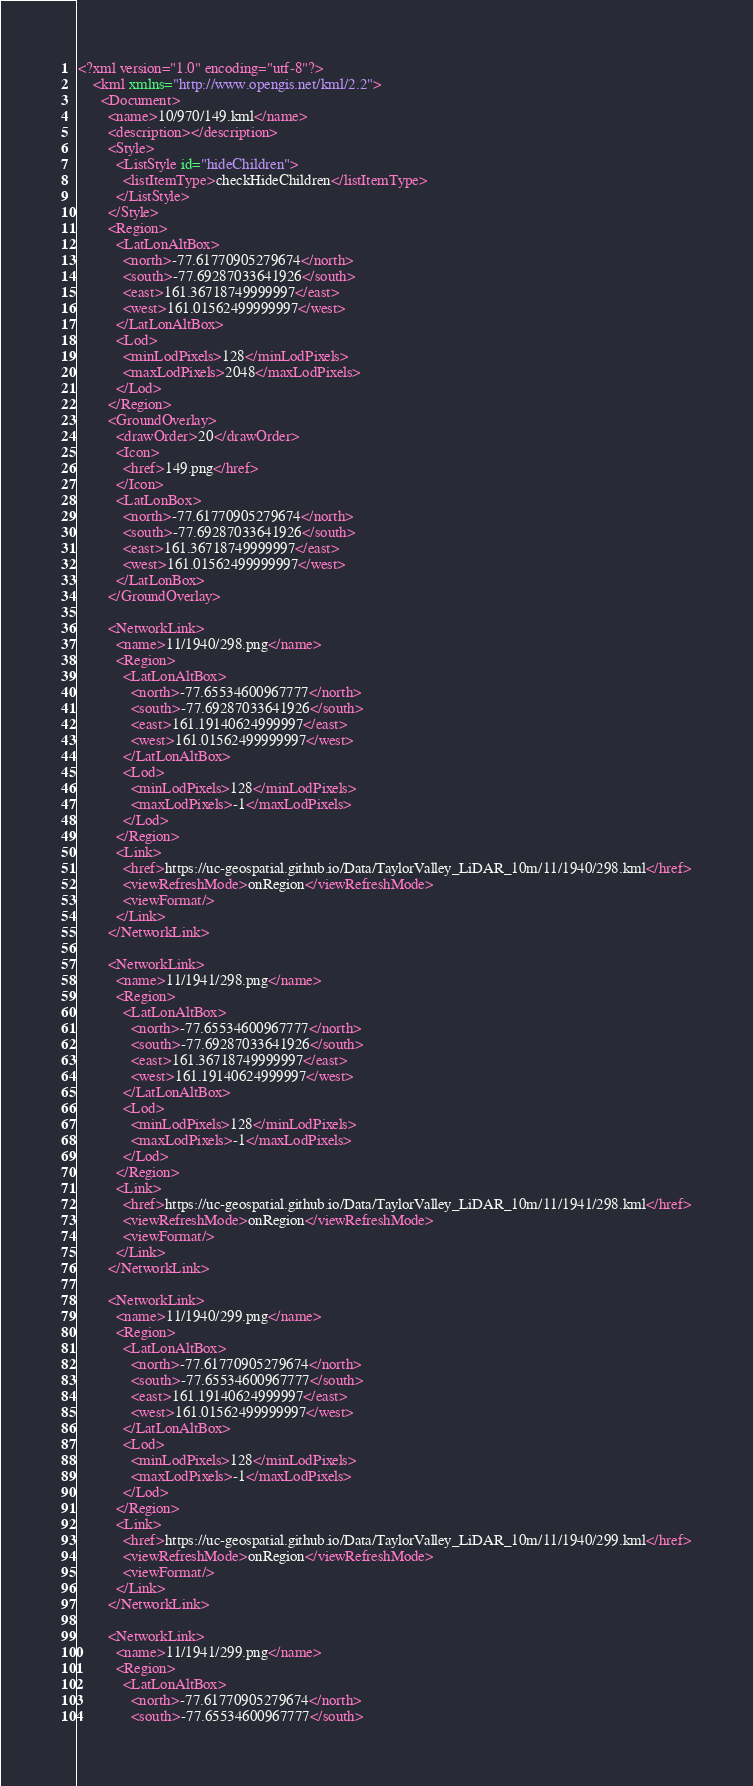Convert code to text. <code><loc_0><loc_0><loc_500><loc_500><_XML_><?xml version="1.0" encoding="utf-8"?>
    <kml xmlns="http://www.opengis.net/kml/2.2">
      <Document>
        <name>10/970/149.kml</name>
        <description></description>
        <Style>
          <ListStyle id="hideChildren">
            <listItemType>checkHideChildren</listItemType>
          </ListStyle>
        </Style>
        <Region>
          <LatLonAltBox>
            <north>-77.61770905279674</north>
            <south>-77.69287033641926</south>
            <east>161.36718749999997</east>
            <west>161.01562499999997</west>
          </LatLonAltBox>
          <Lod>
            <minLodPixels>128</minLodPixels>
            <maxLodPixels>2048</maxLodPixels>
          </Lod>
        </Region>
        <GroundOverlay>
          <drawOrder>20</drawOrder>
          <Icon>
            <href>149.png</href>
          </Icon>
          <LatLonBox>
            <north>-77.61770905279674</north>
            <south>-77.69287033641926</south>
            <east>161.36718749999997</east>
            <west>161.01562499999997</west>
          </LatLonBox>
        </GroundOverlay>
    
        <NetworkLink>
          <name>11/1940/298.png</name>
          <Region>
            <LatLonAltBox>
              <north>-77.65534600967777</north>
              <south>-77.69287033641926</south>
              <east>161.19140624999997</east>
              <west>161.01562499999997</west>
            </LatLonAltBox>
            <Lod>
              <minLodPixels>128</minLodPixels>
              <maxLodPixels>-1</maxLodPixels>
            </Lod>
          </Region>
          <Link>
            <href>https://uc-geospatial.github.io/Data/TaylorValley_LiDAR_10m/11/1940/298.kml</href>
            <viewRefreshMode>onRegion</viewRefreshMode>
            <viewFormat/>
          </Link>
        </NetworkLink>
            
        <NetworkLink>
          <name>11/1941/298.png</name>
          <Region>
            <LatLonAltBox>
              <north>-77.65534600967777</north>
              <south>-77.69287033641926</south>
              <east>161.36718749999997</east>
              <west>161.19140624999997</west>
            </LatLonAltBox>
            <Lod>
              <minLodPixels>128</minLodPixels>
              <maxLodPixels>-1</maxLodPixels>
            </Lod>
          </Region>
          <Link>
            <href>https://uc-geospatial.github.io/Data/TaylorValley_LiDAR_10m/11/1941/298.kml</href>
            <viewRefreshMode>onRegion</viewRefreshMode>
            <viewFormat/>
          </Link>
        </NetworkLink>
            
        <NetworkLink>
          <name>11/1940/299.png</name>
          <Region>
            <LatLonAltBox>
              <north>-77.61770905279674</north>
              <south>-77.65534600967777</south>
              <east>161.19140624999997</east>
              <west>161.01562499999997</west>
            </LatLonAltBox>
            <Lod>
              <minLodPixels>128</minLodPixels>
              <maxLodPixels>-1</maxLodPixels>
            </Lod>
          </Region>
          <Link>
            <href>https://uc-geospatial.github.io/Data/TaylorValley_LiDAR_10m/11/1940/299.kml</href>
            <viewRefreshMode>onRegion</viewRefreshMode>
            <viewFormat/>
          </Link>
        </NetworkLink>
            
        <NetworkLink>
          <name>11/1941/299.png</name>
          <Region>
            <LatLonAltBox>
              <north>-77.61770905279674</north>
              <south>-77.65534600967777</south></code> 